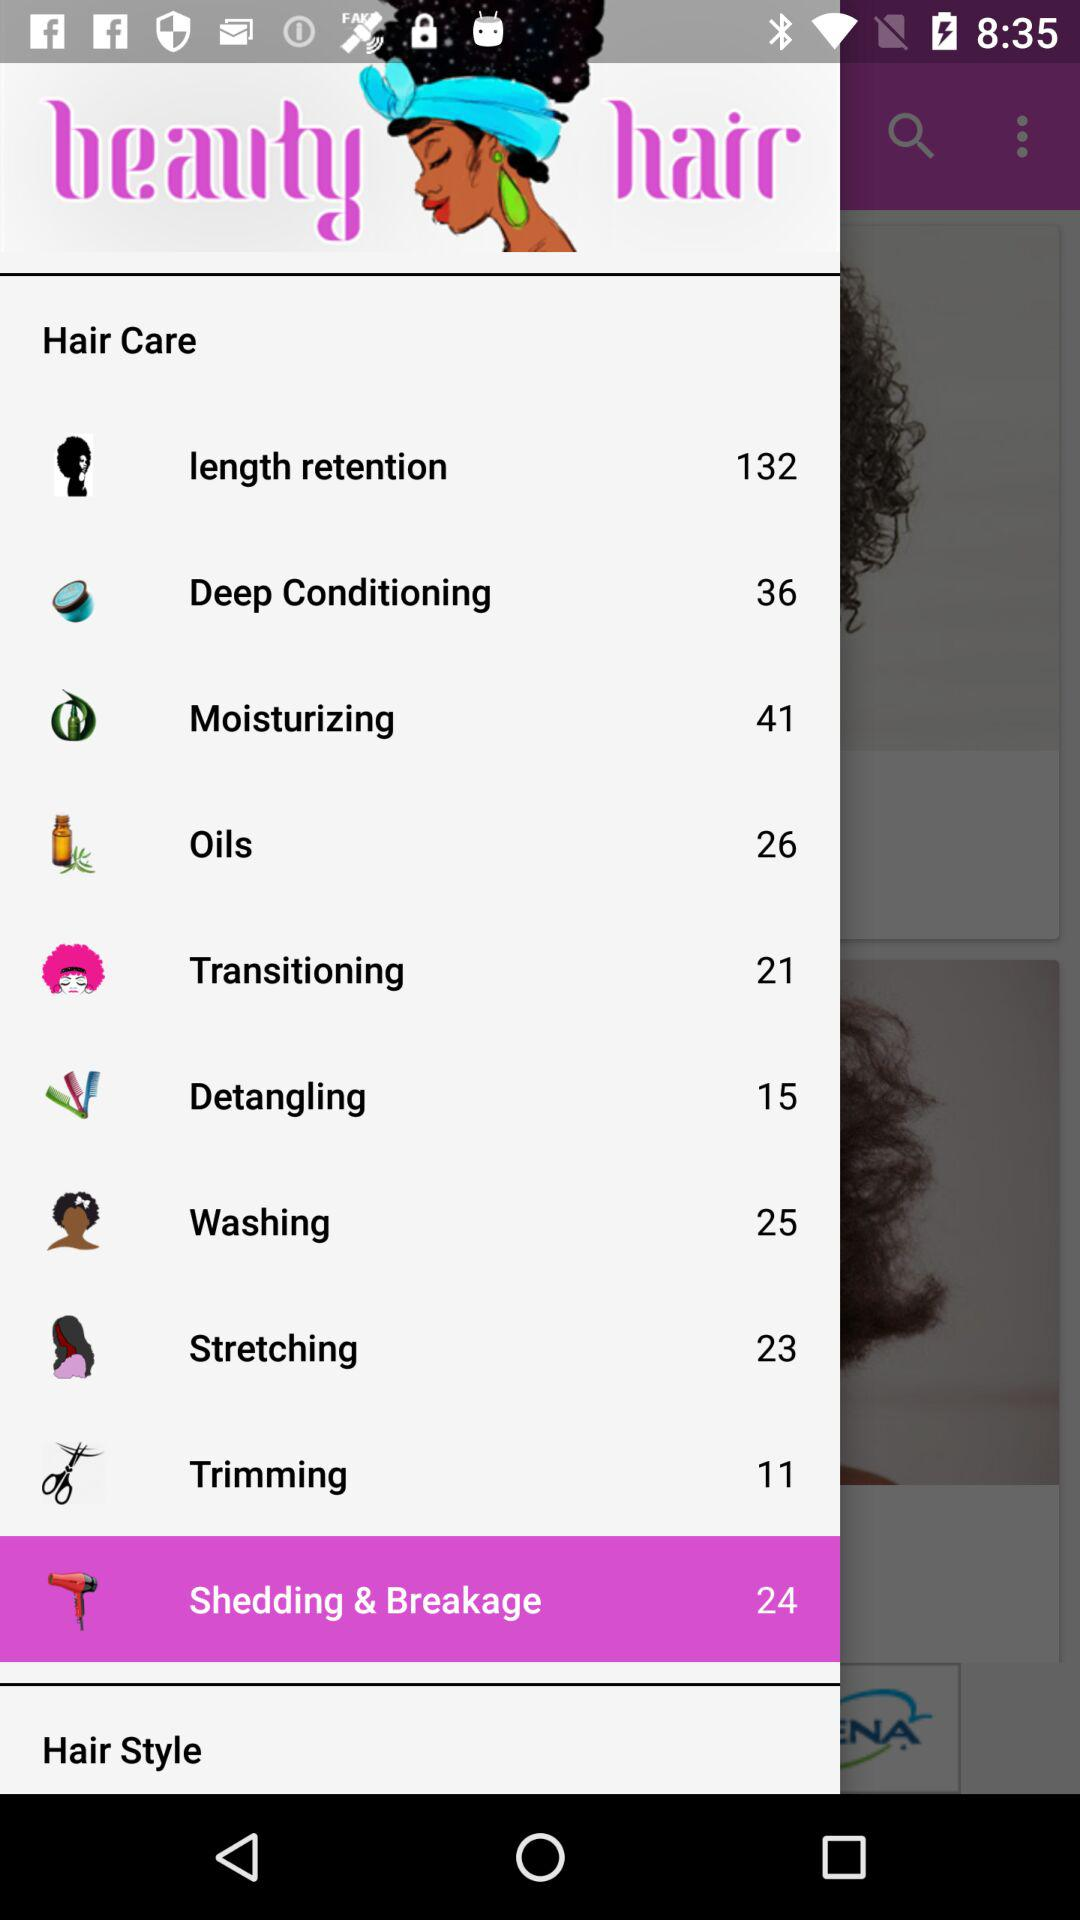How many items are there in "length retention"? There are 132 items. 